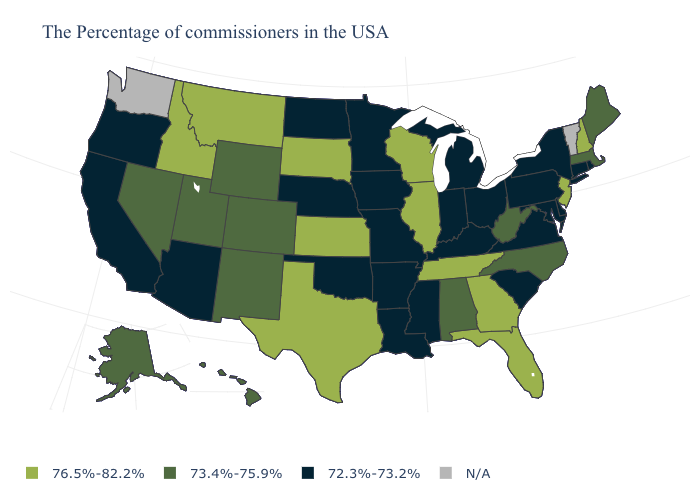Name the states that have a value in the range 72.3%-73.2%?
Keep it brief. Rhode Island, Connecticut, New York, Delaware, Maryland, Pennsylvania, Virginia, South Carolina, Ohio, Michigan, Kentucky, Indiana, Mississippi, Louisiana, Missouri, Arkansas, Minnesota, Iowa, Nebraska, Oklahoma, North Dakota, Arizona, California, Oregon. Name the states that have a value in the range 76.5%-82.2%?
Quick response, please. New Hampshire, New Jersey, Florida, Georgia, Tennessee, Wisconsin, Illinois, Kansas, Texas, South Dakota, Montana, Idaho. Name the states that have a value in the range 72.3%-73.2%?
Answer briefly. Rhode Island, Connecticut, New York, Delaware, Maryland, Pennsylvania, Virginia, South Carolina, Ohio, Michigan, Kentucky, Indiana, Mississippi, Louisiana, Missouri, Arkansas, Minnesota, Iowa, Nebraska, Oklahoma, North Dakota, Arizona, California, Oregon. What is the value of New Mexico?
Short answer required. 73.4%-75.9%. Does Hawaii have the lowest value in the USA?
Write a very short answer. No. Name the states that have a value in the range N/A?
Be succinct. Vermont, Washington. Name the states that have a value in the range 73.4%-75.9%?
Write a very short answer. Maine, Massachusetts, North Carolina, West Virginia, Alabama, Wyoming, Colorado, New Mexico, Utah, Nevada, Alaska, Hawaii. Which states have the highest value in the USA?
Be succinct. New Hampshire, New Jersey, Florida, Georgia, Tennessee, Wisconsin, Illinois, Kansas, Texas, South Dakota, Montana, Idaho. Does Ohio have the highest value in the MidWest?
Short answer required. No. Does Nevada have the highest value in the West?
Give a very brief answer. No. What is the value of Alabama?
Write a very short answer. 73.4%-75.9%. Name the states that have a value in the range N/A?
Write a very short answer. Vermont, Washington. What is the lowest value in the USA?
Write a very short answer. 72.3%-73.2%. What is the value of New Jersey?
Answer briefly. 76.5%-82.2%. 